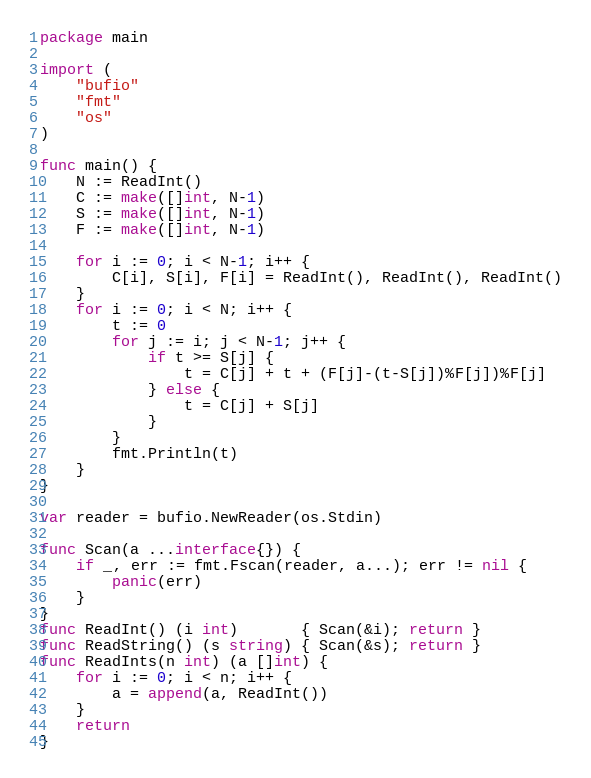Convert code to text. <code><loc_0><loc_0><loc_500><loc_500><_Go_>package main

import (
	"bufio"
	"fmt"
	"os"
)

func main() {
	N := ReadInt()
	C := make([]int, N-1)
	S := make([]int, N-1)
	F := make([]int, N-1)

	for i := 0; i < N-1; i++ {
		C[i], S[i], F[i] = ReadInt(), ReadInt(), ReadInt()
	}
	for i := 0; i < N; i++ {
		t := 0
		for j := i; j < N-1; j++ {
			if t >= S[j] {
				t = C[j] + t + (F[j]-(t-S[j])%F[j])%F[j]
			} else {
				t = C[j] + S[j]
			}
		}
		fmt.Println(t)
	}
}

var reader = bufio.NewReader(os.Stdin)

func Scan(a ...interface{}) {
	if _, err := fmt.Fscan(reader, a...); err != nil {
		panic(err)
	}
}
func ReadInt() (i int)       { Scan(&i); return }
func ReadString() (s string) { Scan(&s); return }
func ReadInts(n int) (a []int) {
	for i := 0; i < n; i++ {
		a = append(a, ReadInt())
	}
	return
}
</code> 